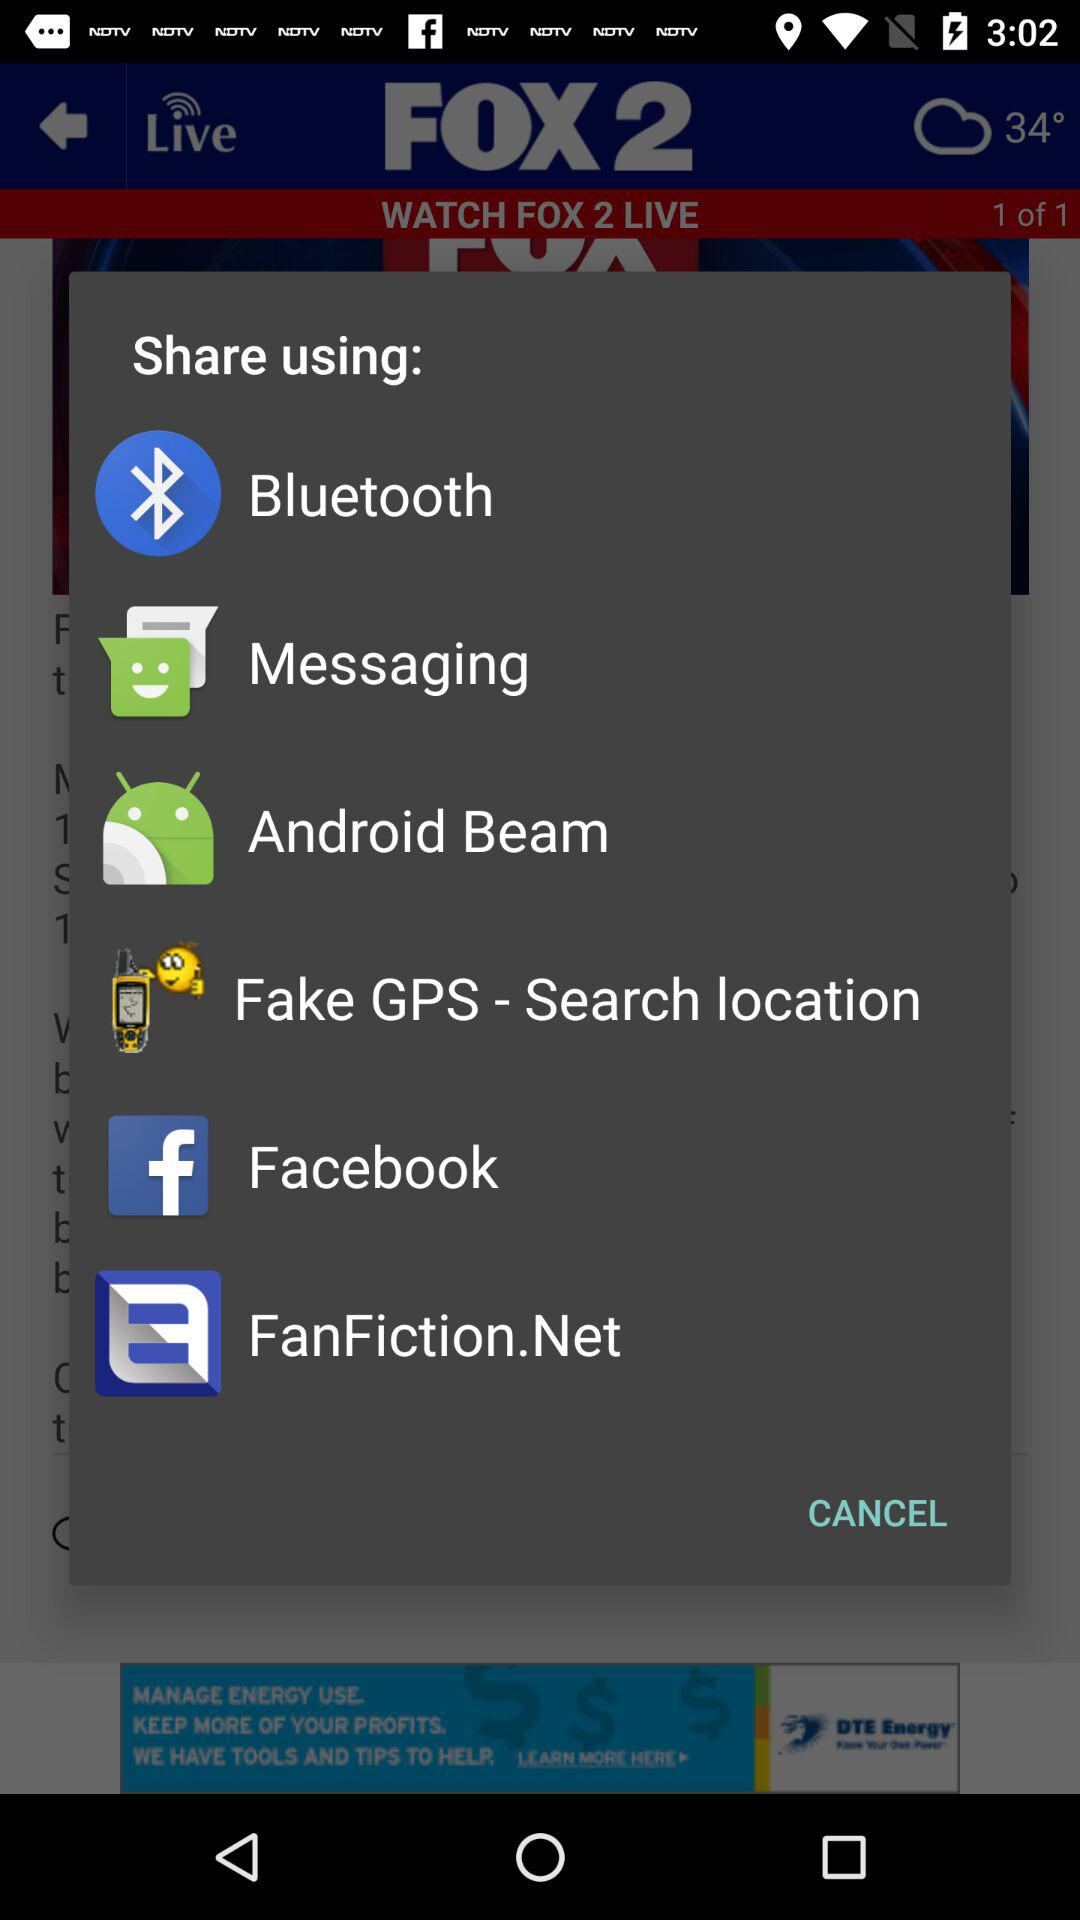What is the channel name? The channel name is FOX 2. 